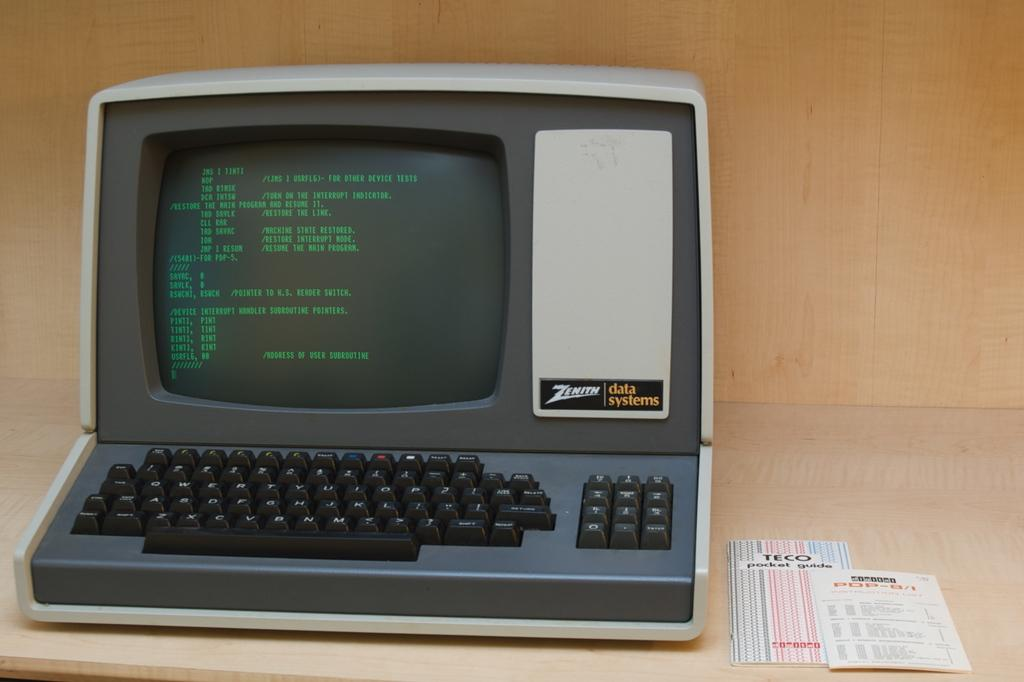Provide a one-sentence caption for the provided image. An old Zenith Data Systems computer with a green monitor. 